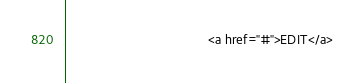<code> <loc_0><loc_0><loc_500><loc_500><_PHP_>										<a href="#">EDIT</a></code> 